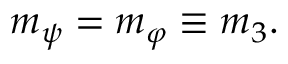Convert formula to latex. <formula><loc_0><loc_0><loc_500><loc_500>\begin{array} { r } { m _ { \psi } = m _ { \varphi } \equiv m _ { 3 } . } \end{array}</formula> 